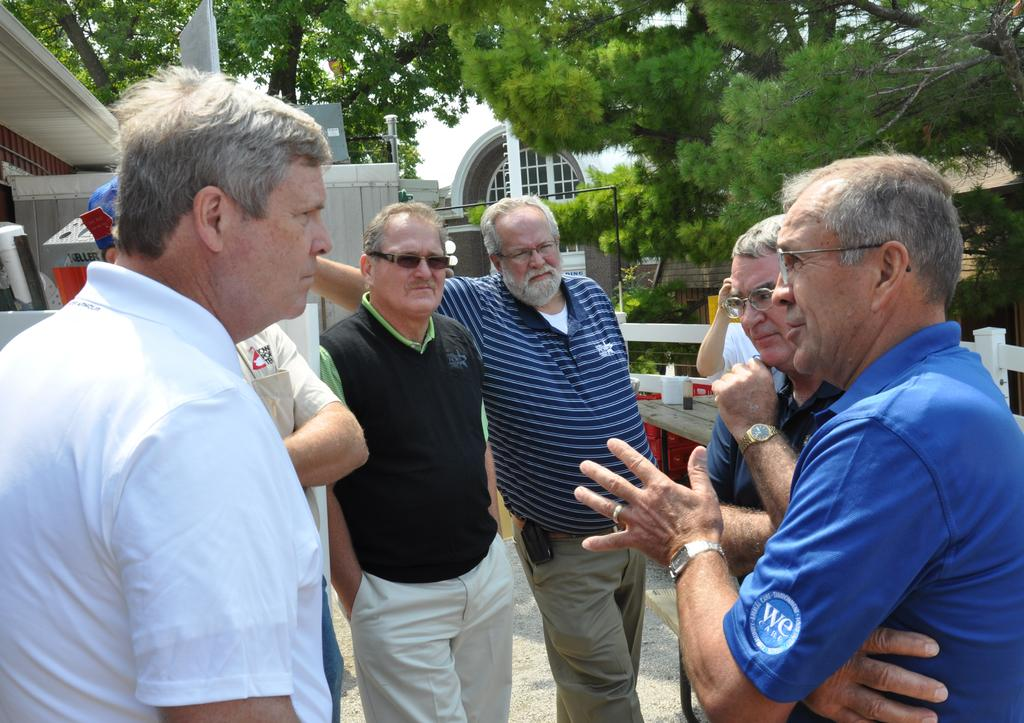What is happening in the center of the image? There are people standing in the center of the image. What can be seen in the distance behind the people? There are buildings, trees, and fences in the background of the image. What type of soup is being served in the image? There is no soup present in the image. What word is written on the buildings in the background? There is no text visible on the buildings in the image, so it is not possible to determine any words written on them. 